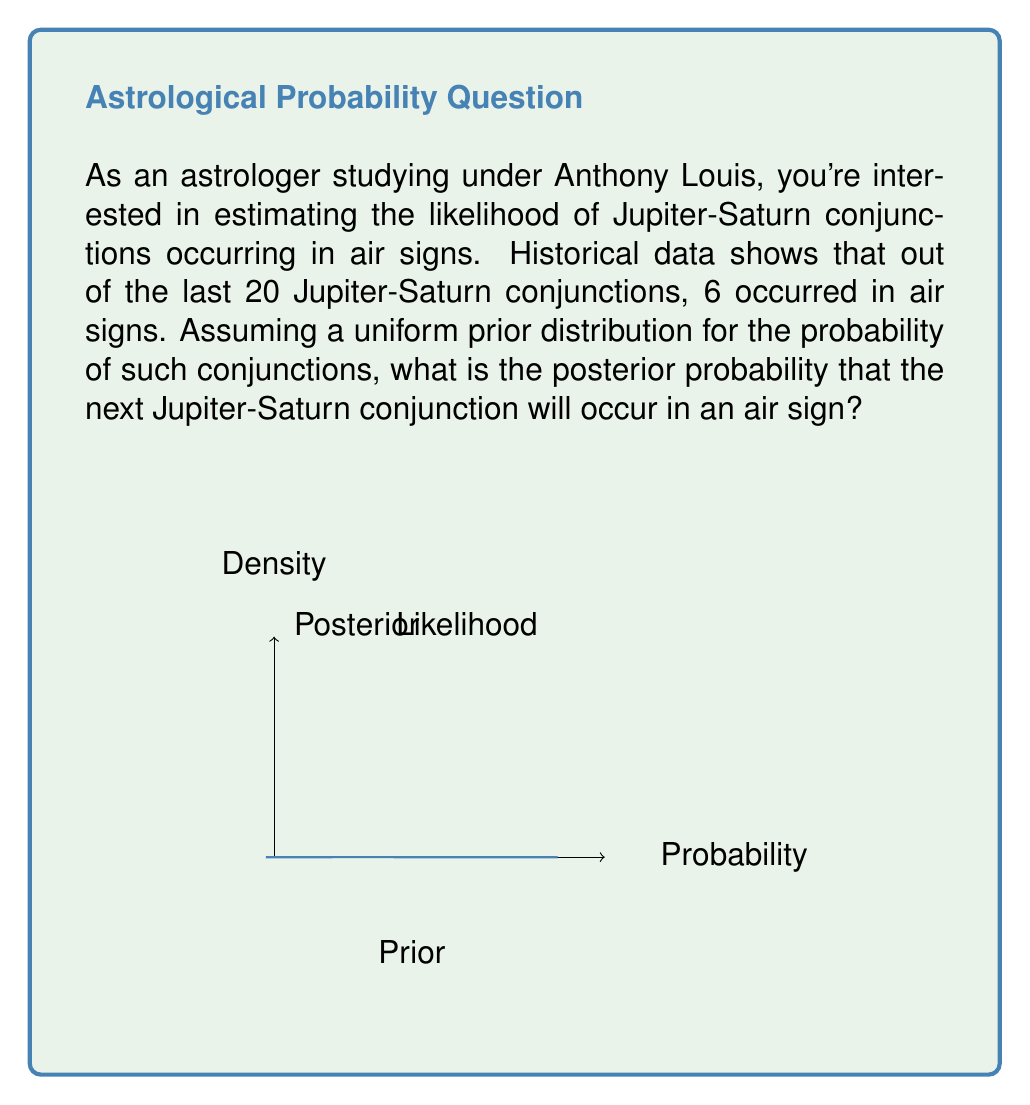Show me your answer to this math problem. Let's approach this problem using Bayesian inference:

1) Let $\theta$ be the probability of a Jupiter-Saturn conjunction occurring in an air sign.

2) Our prior belief is uniform, which means $p(\theta) = 1$ for $0 \leq \theta \leq 1$.

3) The likelihood function follows a binomial distribution:

   $p(data|\theta) = \binom{20}{6} \theta^6 (1-\theta)^{14}$

4) By Bayes' theorem:

   $p(\theta|data) \propto p(data|\theta) \cdot p(\theta)$

5) Since the prior is uniform (constant), the posterior is proportional to the likelihood:

   $p(\theta|data) \propto \theta^6 (1-\theta)^{14}$

6) This is a Beta distribution with parameters $\alpha = 7$ and $\beta = 15$:

   $p(\theta|data) = \text{Beta}(\theta|7, 15)$

7) The expected value of this Beta distribution is our posterior probability:

   $E[\theta|data] = \frac{\alpha}{\alpha + \beta} = \frac{7}{7 + 15} = \frac{7}{22} \approx 0.3182$

Therefore, based on the historical data and our uniform prior, the posterior probability that the next Jupiter-Saturn conjunction will occur in an air sign is approximately 0.3182 or 31.82%.
Answer: $\frac{7}{22} \approx 0.3182$ 